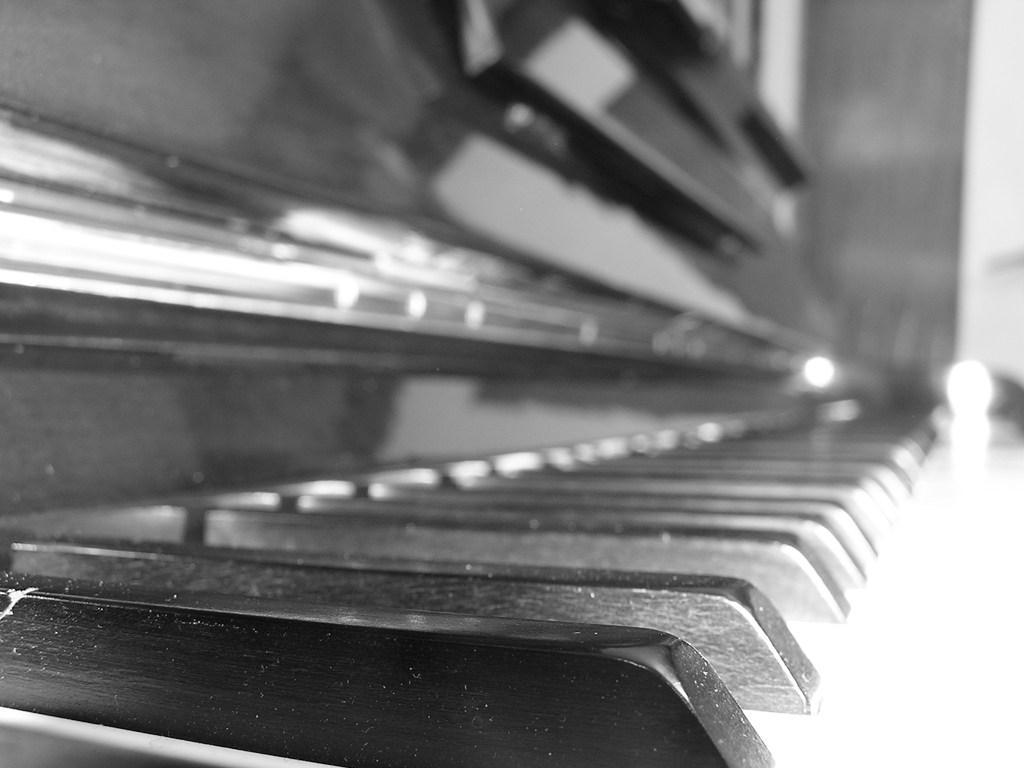What is the color scheme of the image? The image is black and white. What object can be seen in the image? There is a piano in the image. What type of badge is being displayed on the piano in the image? There is no badge present in the image; it only features a piano. 